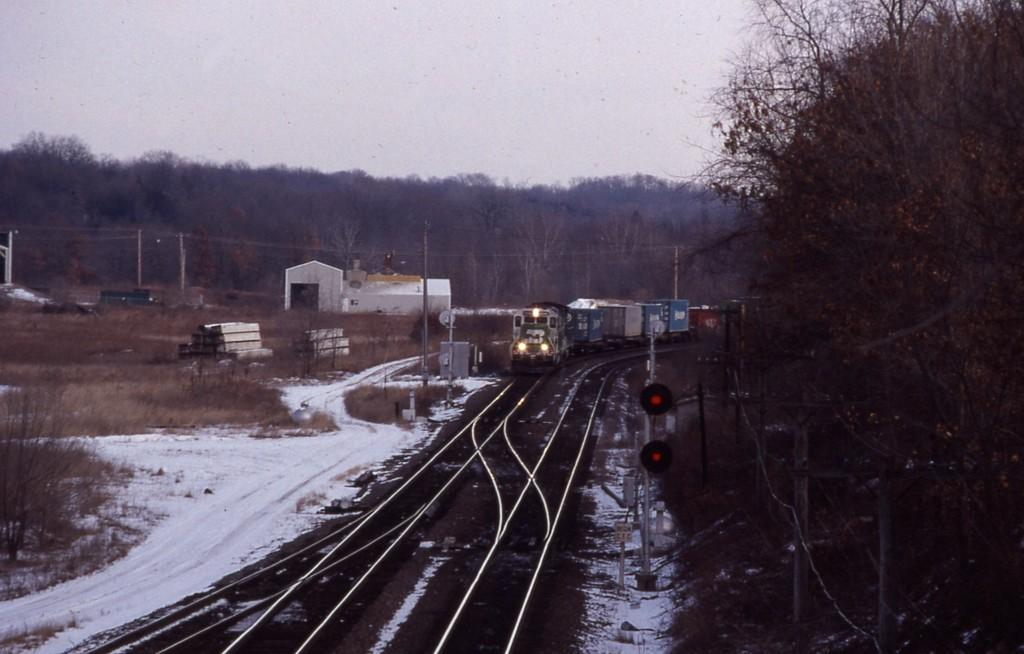What is the main subject of the image? The main subject of the image is a train. What is the train doing in the image? The train is moving on a track. What can be seen in the background of the image? There are trees visible in the image. What other objects can be seen in the image? There are poles and signal lights in the image. Can you tell me how many clocks are hanging on the train in the image? There are no clocks visible on the train in the image. What type of wound can be seen on the train in the image? There are no wounds present on the train in the image. 